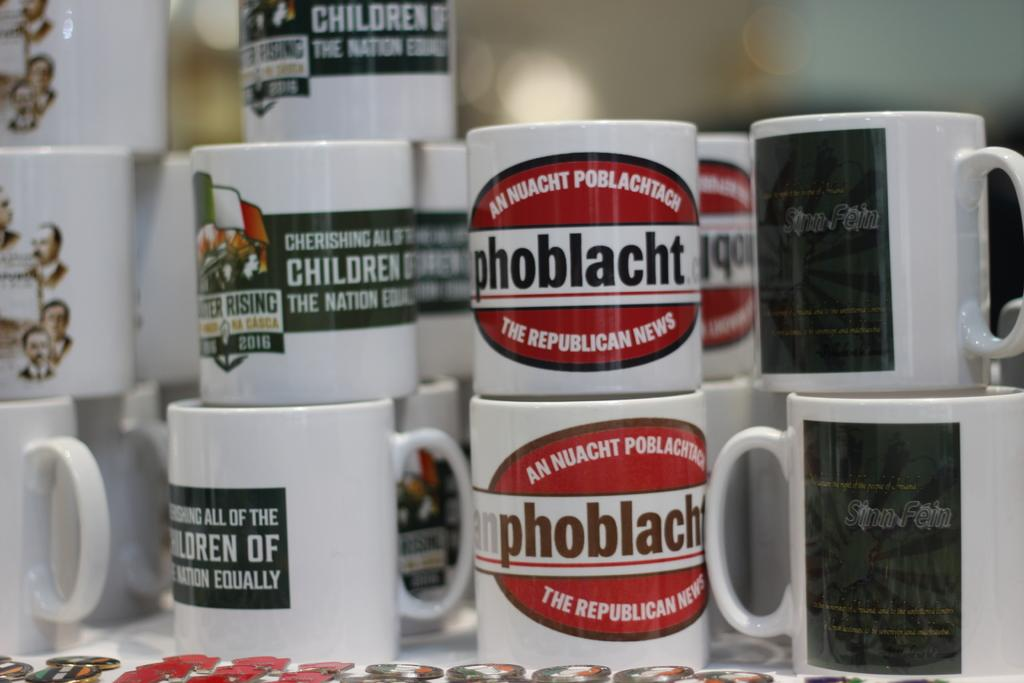Provide a one-sentence caption for the provided image. A white and red coffee mug advertises the Republican News. 